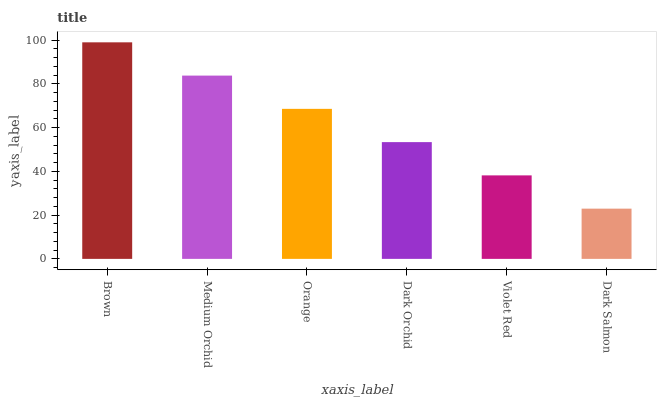Is Dark Salmon the minimum?
Answer yes or no. Yes. Is Brown the maximum?
Answer yes or no. Yes. Is Medium Orchid the minimum?
Answer yes or no. No. Is Medium Orchid the maximum?
Answer yes or no. No. Is Brown greater than Medium Orchid?
Answer yes or no. Yes. Is Medium Orchid less than Brown?
Answer yes or no. Yes. Is Medium Orchid greater than Brown?
Answer yes or no. No. Is Brown less than Medium Orchid?
Answer yes or no. No. Is Orange the high median?
Answer yes or no. Yes. Is Dark Orchid the low median?
Answer yes or no. Yes. Is Dark Orchid the high median?
Answer yes or no. No. Is Brown the low median?
Answer yes or no. No. 